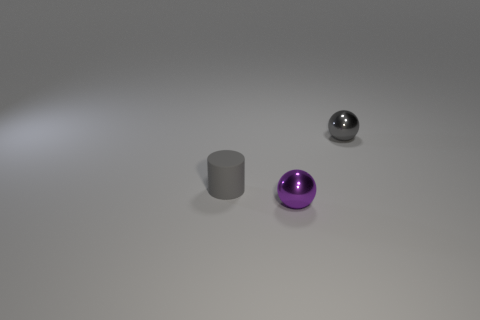Are there any other things of the same color as the small matte cylinder?
Your response must be concise. Yes. There is a tiny metal thing that is behind the small rubber cylinder; does it have the same color as the thing left of the purple metallic thing?
Provide a succinct answer. Yes. What size is the gray cylinder?
Your answer should be very brief. Small. What is the size of the gray metal object that is the same shape as the purple metal object?
Ensure brevity in your answer.  Small. There is a gray object left of the tiny purple sphere; how many gray balls are to the left of it?
Make the answer very short. 0. Does the purple sphere in front of the small rubber thing have the same material as the tiny cylinder that is behind the purple metallic object?
Keep it short and to the point. No. How many other purple metallic things are the same shape as the purple metal object?
Offer a terse response. 0. How many small objects are the same color as the tiny cylinder?
Provide a short and direct response. 1. Do the object to the left of the small purple shiny ball and the thing that is on the right side of the small purple sphere have the same shape?
Offer a terse response. No. There is a gray thing on the left side of the metal object in front of the small gray metallic thing; what number of cylinders are behind it?
Keep it short and to the point. 0. 